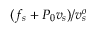<formula> <loc_0><loc_0><loc_500><loc_500>( f _ { s } + P _ { 0 } v _ { s } ) / v _ { s } ^ { o }</formula> 